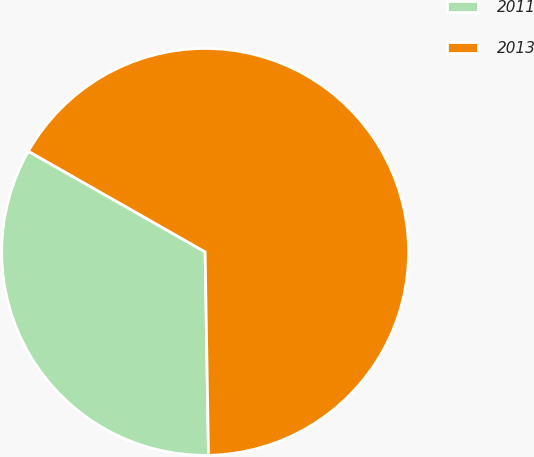<chart> <loc_0><loc_0><loc_500><loc_500><pie_chart><fcel>2011<fcel>2013<nl><fcel>33.5%<fcel>66.5%<nl></chart> 